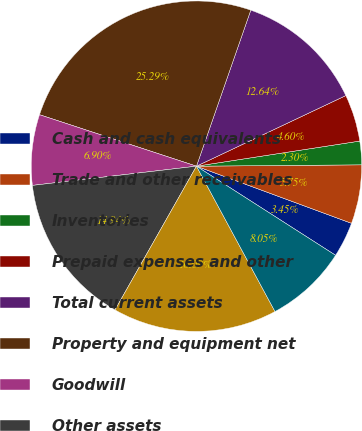Convert chart. <chart><loc_0><loc_0><loc_500><loc_500><pie_chart><fcel>Cash and cash equivalents<fcel>Trade and other receivables<fcel>Inventories<fcel>Prepaid expenses and other<fcel>Total current assets<fcel>Property and equipment net<fcel>Goodwill<fcel>Other assets<fcel>Current portion of long-term<fcel>Accounts payable<nl><fcel>3.45%<fcel>5.75%<fcel>2.3%<fcel>4.6%<fcel>12.64%<fcel>25.29%<fcel>6.9%<fcel>14.94%<fcel>16.09%<fcel>8.05%<nl></chart> 